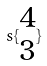Convert formula to latex. <formula><loc_0><loc_0><loc_500><loc_500>s \{ \begin{matrix} 4 \\ 3 \end{matrix} \}</formula> 